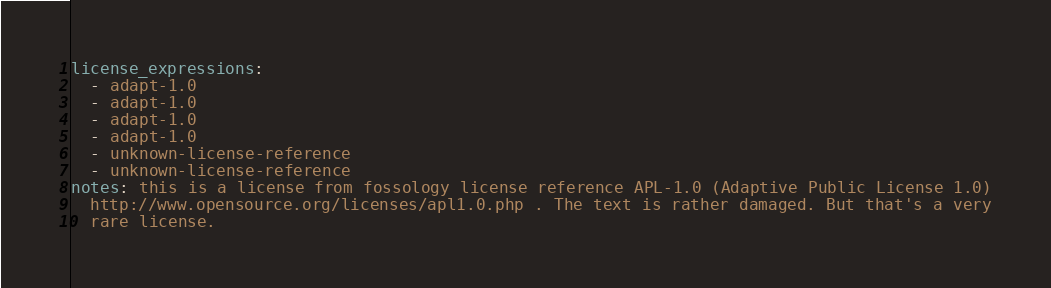Convert code to text. <code><loc_0><loc_0><loc_500><loc_500><_YAML_>license_expressions:
  - adapt-1.0
  - adapt-1.0
  - adapt-1.0
  - adapt-1.0
  - unknown-license-reference
  - unknown-license-reference
notes: this is a license from fossology license reference APL-1.0 (Adaptive Public License 1.0)
  http://www.opensource.org/licenses/apl1.0.php . The text is rather damaged. But that's a very
  rare license.
</code> 